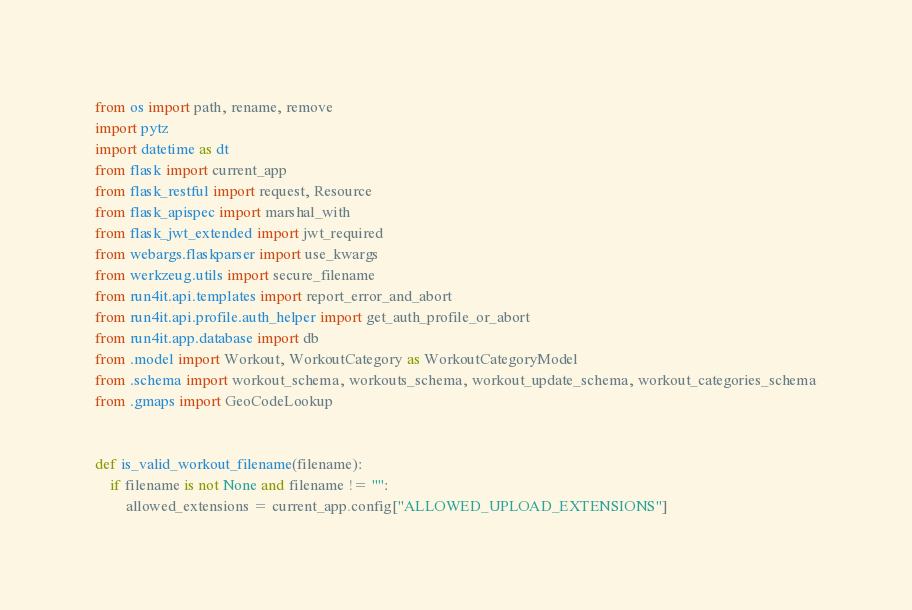<code> <loc_0><loc_0><loc_500><loc_500><_Python_>from os import path, rename, remove
import pytz
import datetime as dt
from flask import current_app
from flask_restful import request, Resource
from flask_apispec import marshal_with
from flask_jwt_extended import jwt_required
from webargs.flaskparser import use_kwargs
from werkzeug.utils import secure_filename
from run4it.api.templates import report_error_and_abort
from run4it.api.profile.auth_helper import get_auth_profile_or_abort
from run4it.app.database import db
from .model import Workout, WorkoutCategory as WorkoutCategoryModel
from .schema import workout_schema, workouts_schema, workout_update_schema, workout_categories_schema
from .gmaps import GeoCodeLookup


def is_valid_workout_filename(filename):
	if filename is not None and filename != "":
		allowed_extensions = current_app.config["ALLOWED_UPLOAD_EXTENSIONS"]</code> 